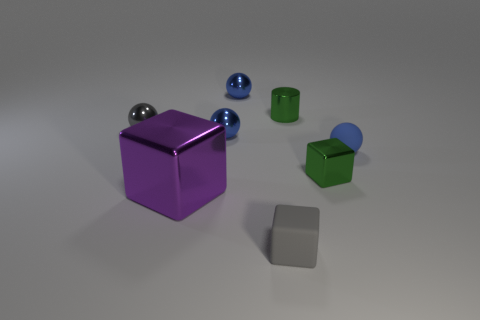Subtract all cyan cylinders. How many blue balls are left? 3 Subtract all red spheres. Subtract all cyan blocks. How many spheres are left? 4 Add 2 big purple shiny objects. How many objects exist? 10 Subtract all cylinders. How many objects are left? 7 Subtract 0 red cylinders. How many objects are left? 8 Subtract all small green balls. Subtract all tiny shiny objects. How many objects are left? 3 Add 7 blue shiny objects. How many blue shiny objects are left? 9 Add 1 large cyan cylinders. How many large cyan cylinders exist? 1 